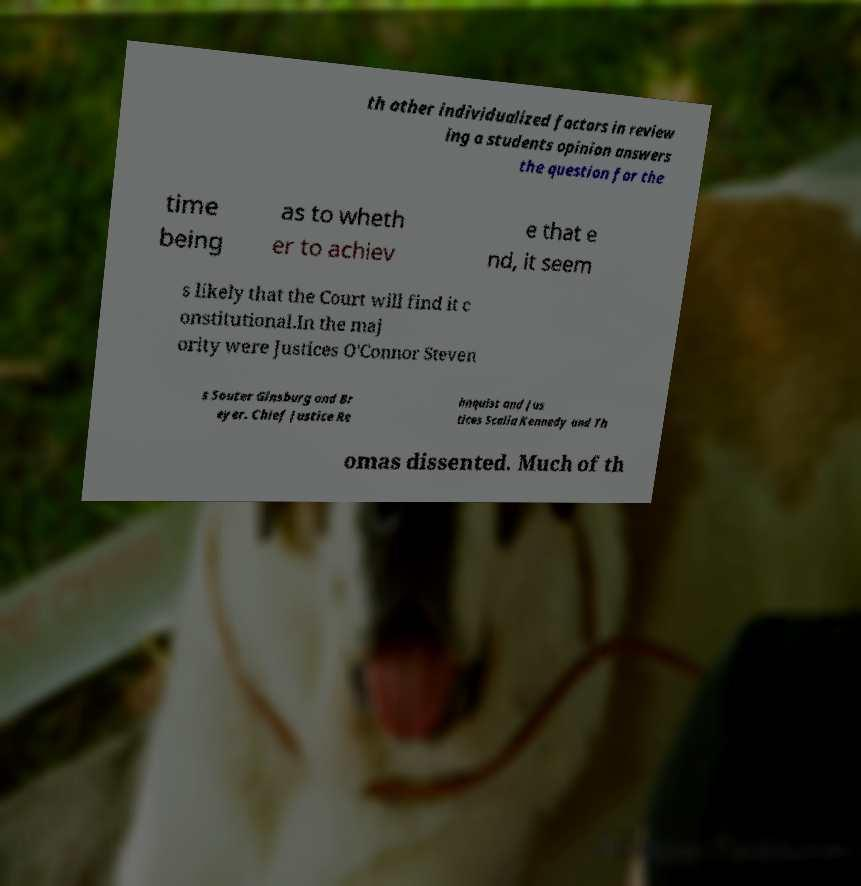Please identify and transcribe the text found in this image. th other individualized factors in review ing a students opinion answers the question for the time being as to wheth er to achiev e that e nd, it seem s likely that the Court will find it c onstitutional.In the maj ority were Justices O'Connor Steven s Souter Ginsburg and Br eyer. Chief Justice Re hnquist and Jus tices Scalia Kennedy and Th omas dissented. Much of th 